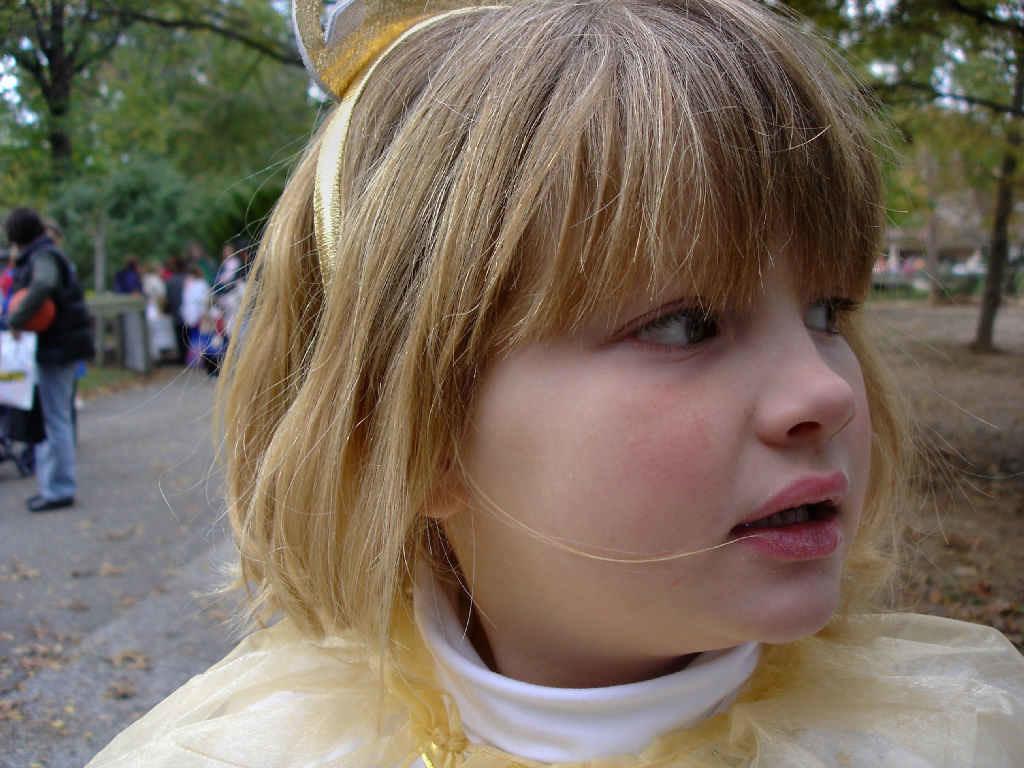Please provide a concise description of this image. In this image there is a girl, there is the road, there are dried leaves on the road, there are persons on the road, there is a man holding an object, at the background of the image there are trees. 